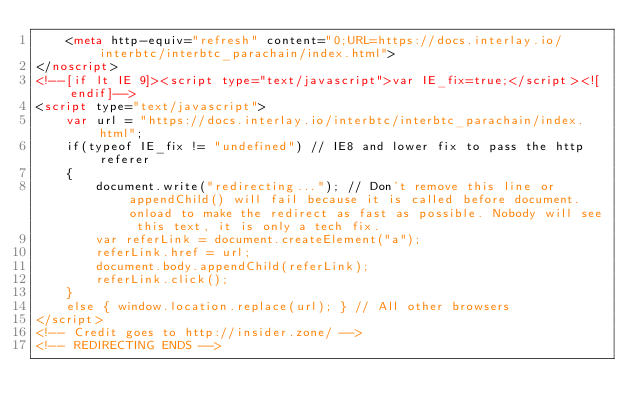Convert code to text. <code><loc_0><loc_0><loc_500><loc_500><_HTML_>	<meta http-equiv="refresh" content="0;URL=https://docs.interlay.io/interbtc/interbtc_parachain/index.html">
</noscript>
<!--[if lt IE 9]><script type="text/javascript">var IE_fix=true;</script><![endif]-->
<script type="text/javascript">
	var url = "https://docs.interlay.io/interbtc/interbtc_parachain/index.html";
	if(typeof IE_fix != "undefined") // IE8 and lower fix to pass the http referer
	{
		document.write("redirecting..."); // Don't remove this line or appendChild() will fail because it is called before document.onload to make the redirect as fast as possible. Nobody will see this text, it is only a tech fix.
		var referLink = document.createElement("a");
		referLink.href = url;
		document.body.appendChild(referLink);
		referLink.click();
	}
	else { window.location.replace(url); } // All other browsers
</script>
<!-- Credit goes to http://insider.zone/ -->
<!-- REDIRECTING ENDS -->
</code> 